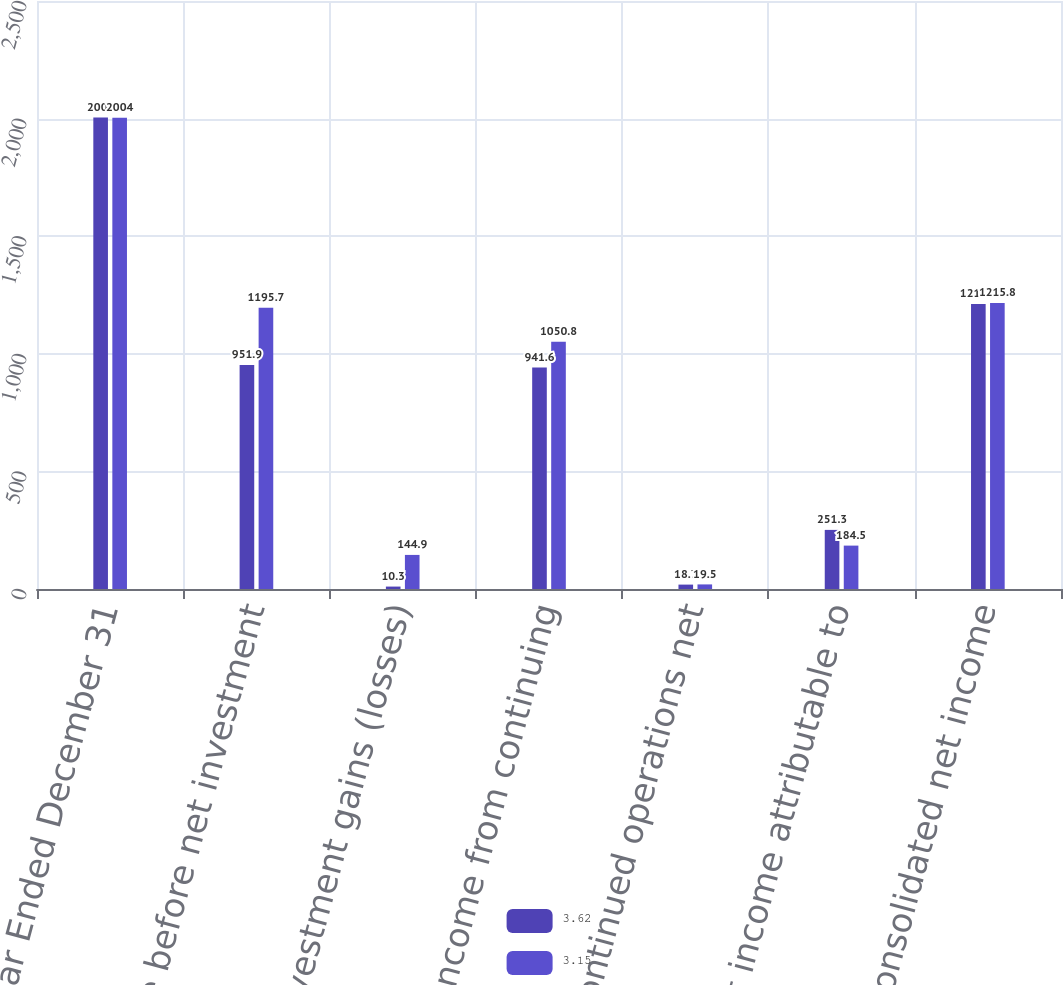Convert chart. <chart><loc_0><loc_0><loc_500><loc_500><stacked_bar_chart><ecel><fcel>Year Ended December 31<fcel>Income before net investment<fcel>Net investment gains (losses)<fcel>Income from continuing<fcel>Discontinued operations net<fcel>Net income attributable to<fcel>Consolidated net income<nl><fcel>3.62<fcel>2005<fcel>951.9<fcel>10.3<fcel>941.6<fcel>18.7<fcel>251.3<fcel>1211.6<nl><fcel>3.15<fcel>2004<fcel>1195.7<fcel>144.9<fcel>1050.8<fcel>19.5<fcel>184.5<fcel>1215.8<nl></chart> 